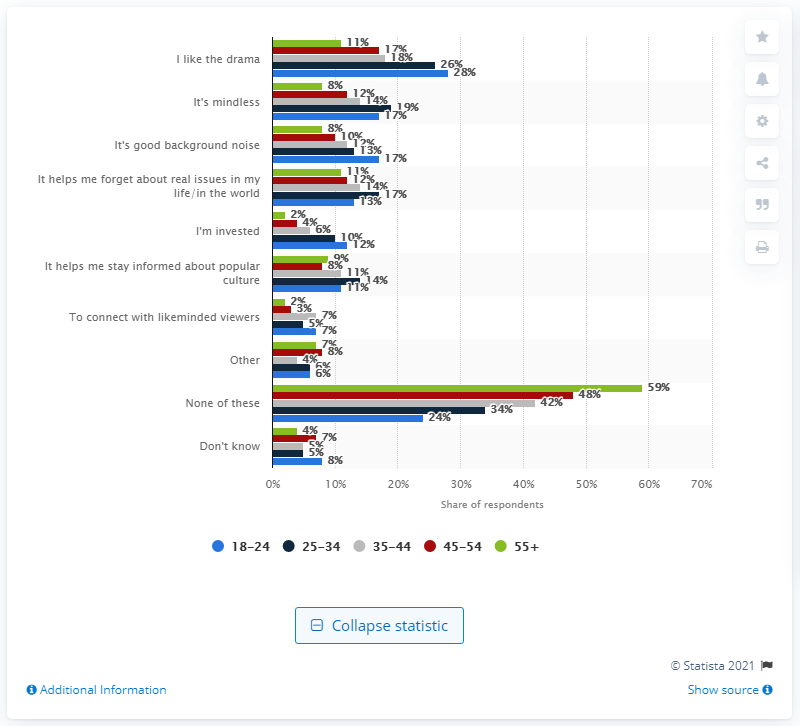Specify some key components in this picture. According to a survey of 18 to 29-year-olds, a significant percentage cited the primary appeal of reality TV as 28. A survey found that 28% of 18 to 29-year-olds believed that the primary appeal of reality TV was its ability to offer a voyeuristic look into people's personal lives. 